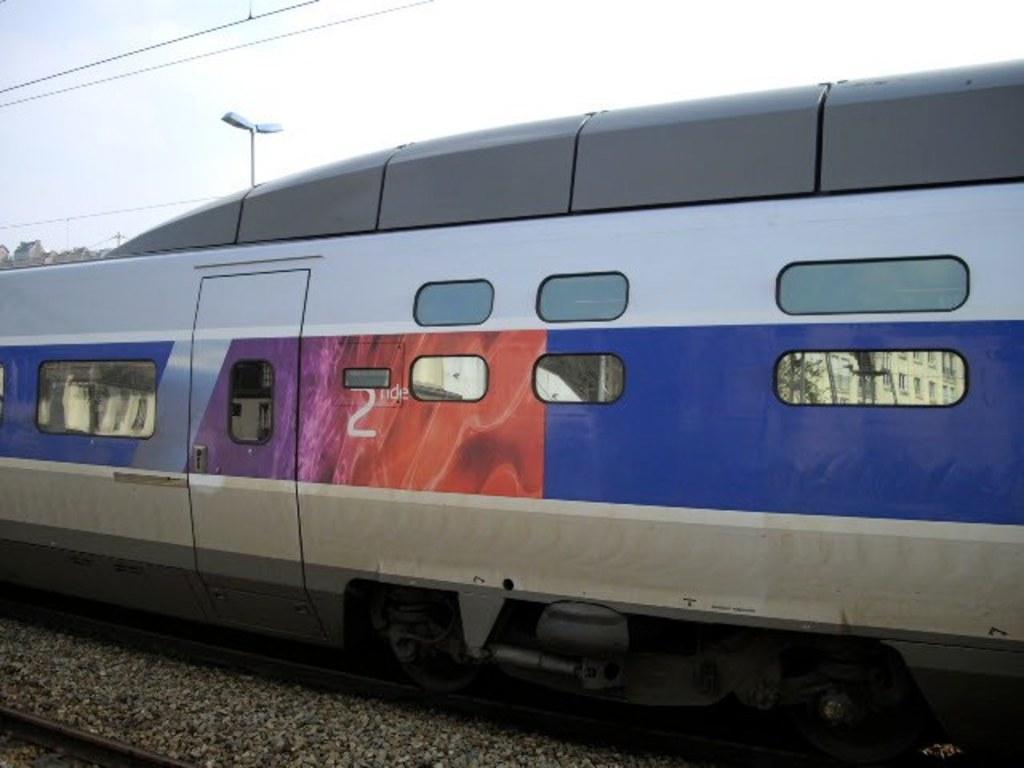Please provide a concise description of this image. In the foreground of the picture there are stones, railway track and train. In the background there are cables, street light and buildings. 